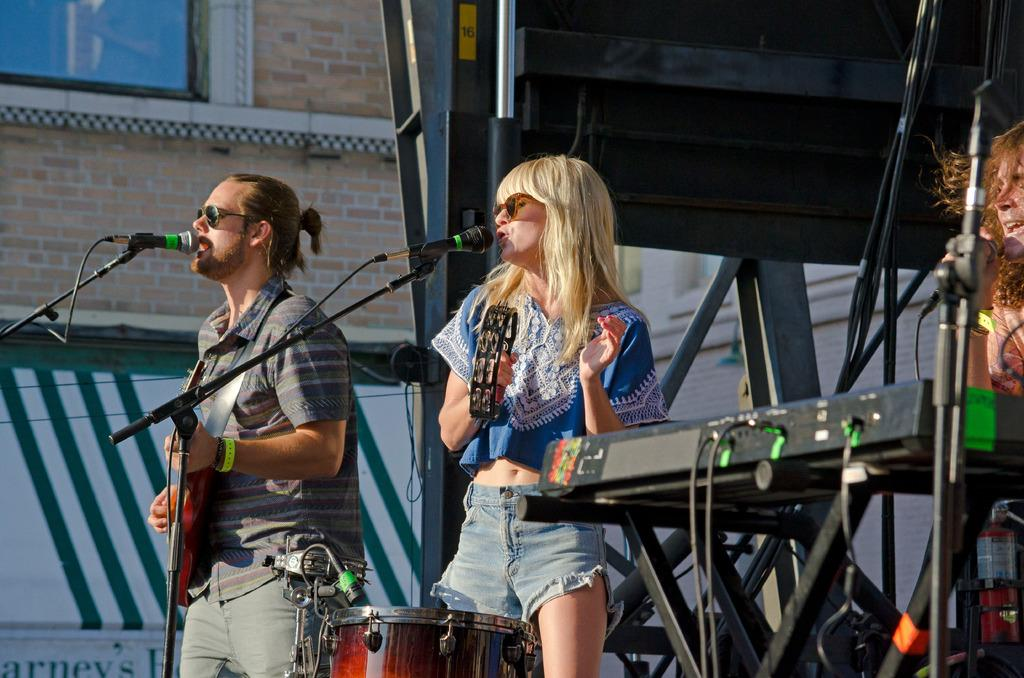How many people are on the stage in the image? There are 3 people on the stage. What are the people on the stage doing? The people are performing by playing musical instruments and singing. What can be seen in the background of the image? There is a building and a window in the background. What type of stew is being served to the audience in the image? There is no mention of stew or any food being served in the image. The focus is on the people on the stage performing with musical instruments and singing. 